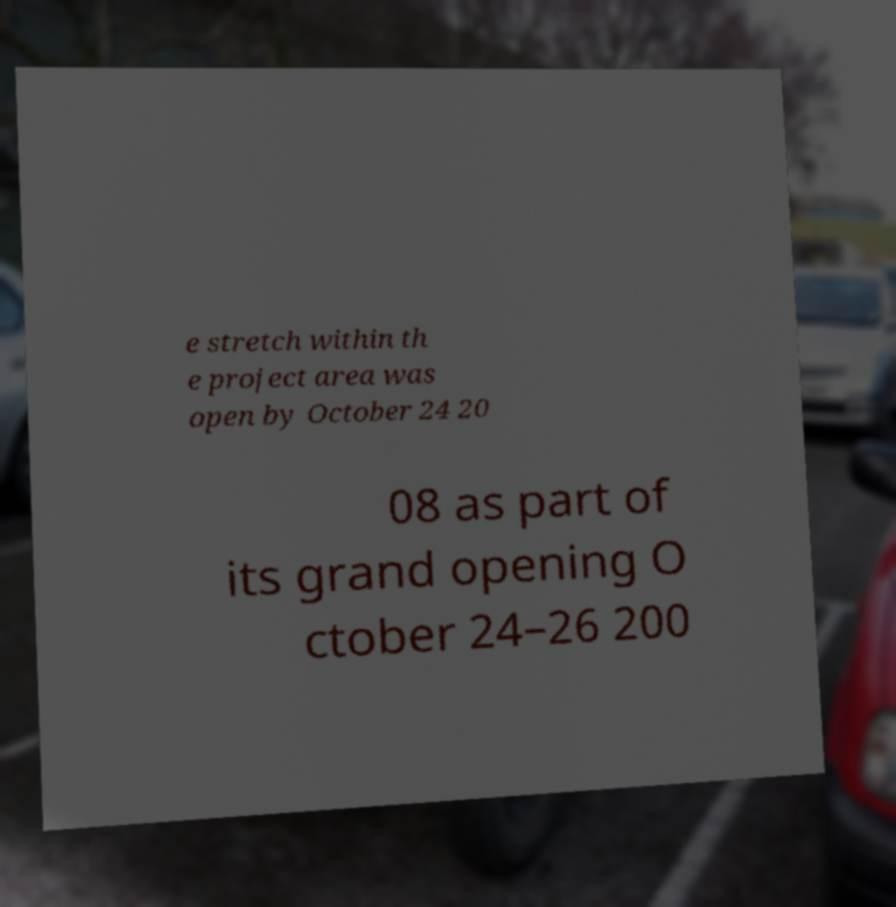Please identify and transcribe the text found in this image. e stretch within th e project area was open by October 24 20 08 as part of its grand opening O ctober 24–26 200 